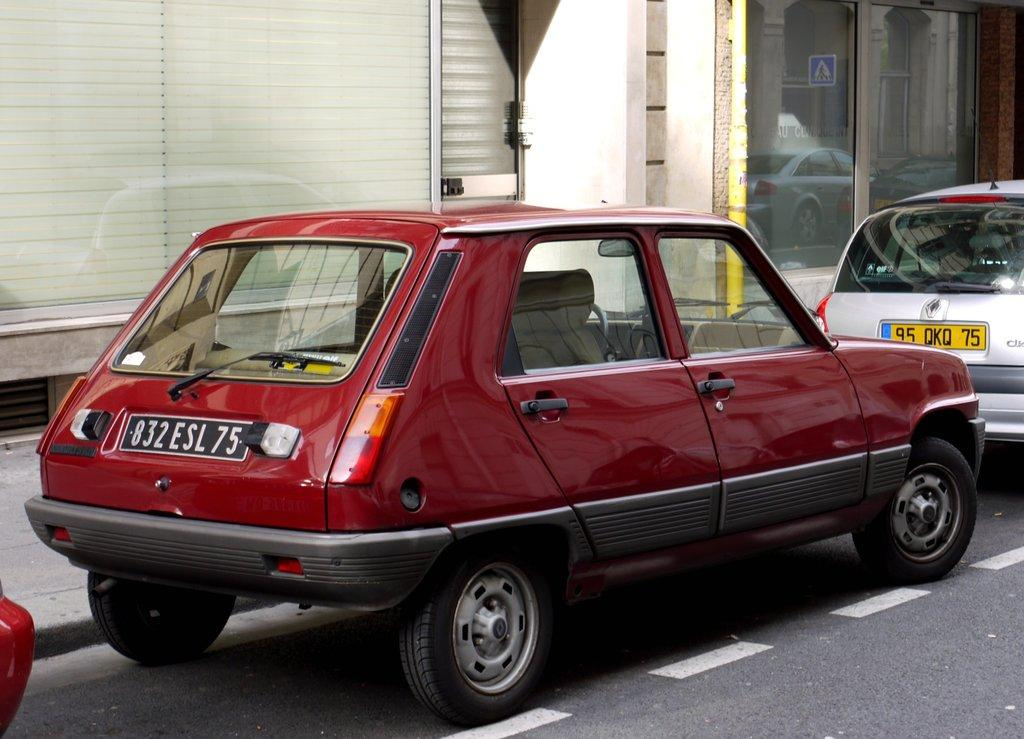What type of transportation can be seen on the road in the image? There are motor vehicles on the road in the image. What is the purpose of the footpath in the image? The footpath is for pedestrians to walk on. What structures are visible in the image? There are buildings visible in the image. What is the reflection of in the image? There is a sign board reflection in the image. What type of humor can be seen in the image? There is no humor present in the image; it depicts motor vehicles on the road, a footpath, buildings, and a sign board reflection. Can you tell me how fast the people are running in the image? There are no people running in the image; it shows motor vehicles on the road, a footpath, buildings, and a sign board reflection. 